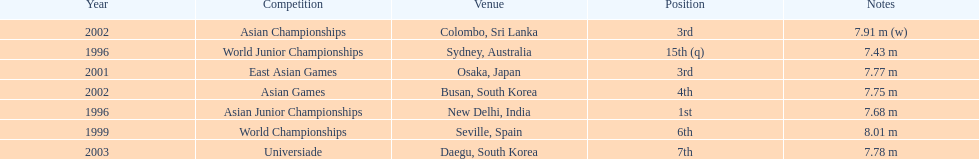How long was huang le's longest jump in 2002? 7.91 m (w). 